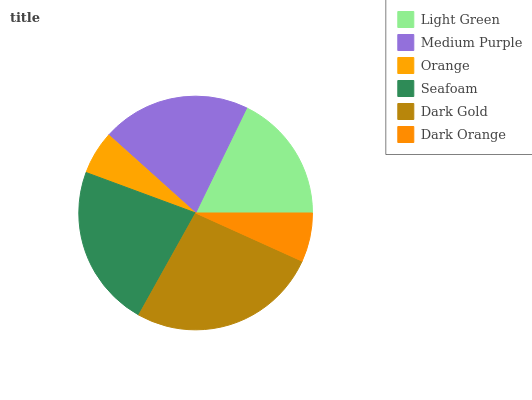Is Orange the minimum?
Answer yes or no. Yes. Is Dark Gold the maximum?
Answer yes or no. Yes. Is Medium Purple the minimum?
Answer yes or no. No. Is Medium Purple the maximum?
Answer yes or no. No. Is Medium Purple greater than Light Green?
Answer yes or no. Yes. Is Light Green less than Medium Purple?
Answer yes or no. Yes. Is Light Green greater than Medium Purple?
Answer yes or no. No. Is Medium Purple less than Light Green?
Answer yes or no. No. Is Medium Purple the high median?
Answer yes or no. Yes. Is Light Green the low median?
Answer yes or no. Yes. Is Light Green the high median?
Answer yes or no. No. Is Medium Purple the low median?
Answer yes or no. No. 